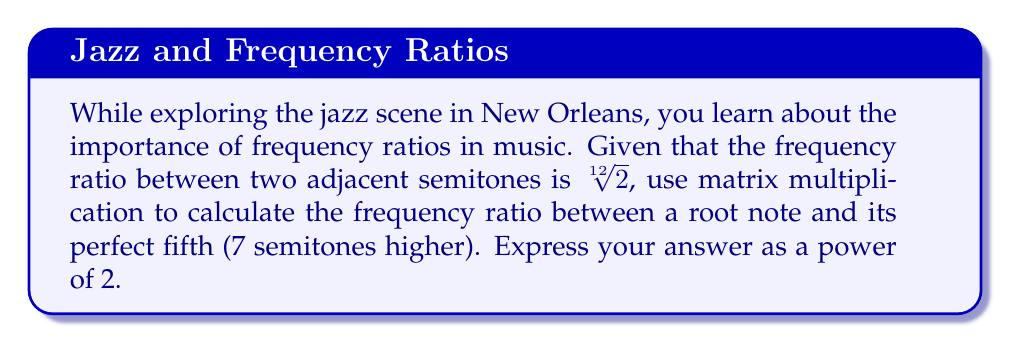What is the answer to this math problem? Let's approach this step-by-step:

1) We can represent the frequency ratio for each semitone as a 1x1 matrix: $[\sqrt[12]{2}]$

2) To find the ratio for 7 semitones, we need to multiply this matrix by itself 7 times:

   $$[\sqrt[12]{2}]^7 = [\sqrt[12]{2}^7] = [2^{7/12}]$$

3) We can simplify this using the properties of exponents:

   $$[2^{7/12}] = [(2^{1/12})^7] = [2^{7/12}]$$

4) Now, we need to express this as a power of 2. We already have it in that form:

   $$[2^{7/12}]$$

5) This can be reduced to a single number:

   $$2^{7/12} \approx 1.4983$$

6) However, the question asks for the answer as a power of 2, so we leave it as $2^{7/12}$.
Answer: $2^{7/12}$ 